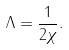Convert formula to latex. <formula><loc_0><loc_0><loc_500><loc_500>\Lambda = \frac { 1 } { 2 \chi } .</formula> 